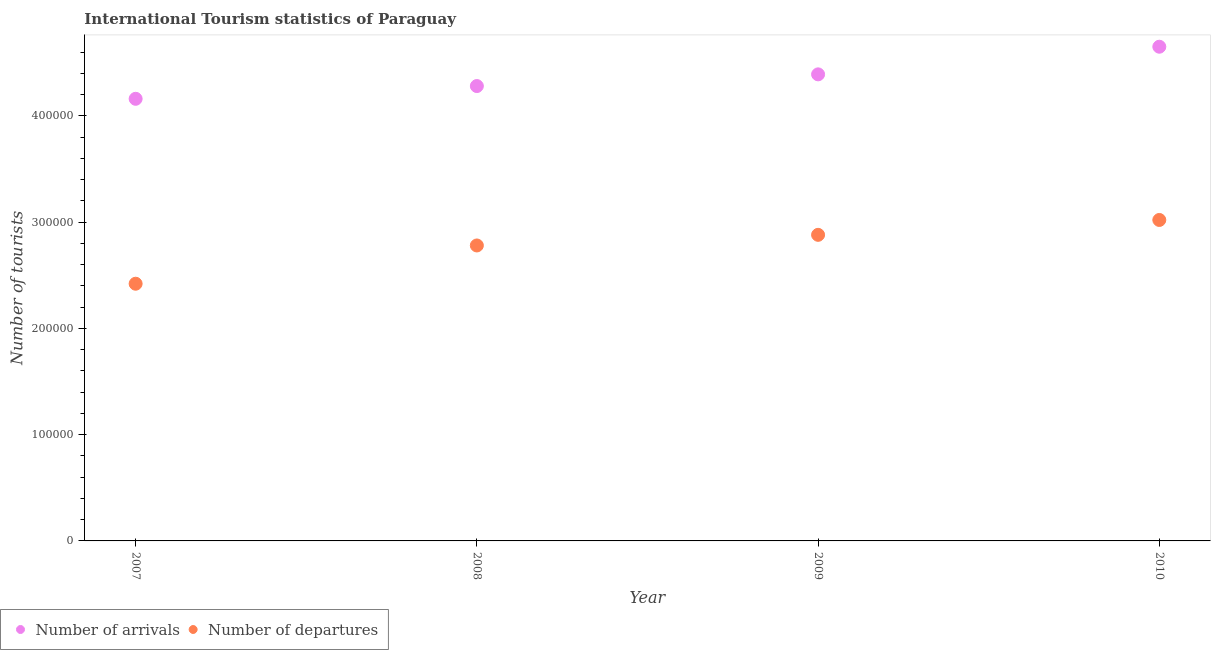Is the number of dotlines equal to the number of legend labels?
Provide a succinct answer. Yes. What is the number of tourist arrivals in 2009?
Provide a succinct answer. 4.39e+05. Across all years, what is the maximum number of tourist departures?
Keep it short and to the point. 3.02e+05. Across all years, what is the minimum number of tourist arrivals?
Keep it short and to the point. 4.16e+05. In which year was the number of tourist departures minimum?
Your answer should be very brief. 2007. What is the total number of tourist arrivals in the graph?
Offer a very short reply. 1.75e+06. What is the difference between the number of tourist departures in 2008 and that in 2009?
Make the answer very short. -10000. What is the difference between the number of tourist arrivals in 2007 and the number of tourist departures in 2009?
Keep it short and to the point. 1.28e+05. What is the average number of tourist arrivals per year?
Give a very brief answer. 4.37e+05. In the year 2009, what is the difference between the number of tourist arrivals and number of tourist departures?
Your answer should be compact. 1.51e+05. What is the ratio of the number of tourist arrivals in 2008 to that in 2009?
Provide a succinct answer. 0.97. What is the difference between the highest and the second highest number of tourist arrivals?
Offer a terse response. 2.60e+04. What is the difference between the highest and the lowest number of tourist arrivals?
Offer a very short reply. 4.90e+04. How many years are there in the graph?
Your answer should be very brief. 4. Does the graph contain any zero values?
Keep it short and to the point. No. Where does the legend appear in the graph?
Provide a short and direct response. Bottom left. How many legend labels are there?
Give a very brief answer. 2. What is the title of the graph?
Provide a short and direct response. International Tourism statistics of Paraguay. What is the label or title of the Y-axis?
Give a very brief answer. Number of tourists. What is the Number of tourists in Number of arrivals in 2007?
Offer a terse response. 4.16e+05. What is the Number of tourists in Number of departures in 2007?
Make the answer very short. 2.42e+05. What is the Number of tourists of Number of arrivals in 2008?
Offer a terse response. 4.28e+05. What is the Number of tourists of Number of departures in 2008?
Keep it short and to the point. 2.78e+05. What is the Number of tourists of Number of arrivals in 2009?
Provide a succinct answer. 4.39e+05. What is the Number of tourists of Number of departures in 2009?
Your answer should be compact. 2.88e+05. What is the Number of tourists in Number of arrivals in 2010?
Keep it short and to the point. 4.65e+05. What is the Number of tourists in Number of departures in 2010?
Provide a short and direct response. 3.02e+05. Across all years, what is the maximum Number of tourists in Number of arrivals?
Keep it short and to the point. 4.65e+05. Across all years, what is the maximum Number of tourists of Number of departures?
Ensure brevity in your answer.  3.02e+05. Across all years, what is the minimum Number of tourists in Number of arrivals?
Your response must be concise. 4.16e+05. Across all years, what is the minimum Number of tourists in Number of departures?
Offer a terse response. 2.42e+05. What is the total Number of tourists in Number of arrivals in the graph?
Your response must be concise. 1.75e+06. What is the total Number of tourists of Number of departures in the graph?
Give a very brief answer. 1.11e+06. What is the difference between the Number of tourists of Number of arrivals in 2007 and that in 2008?
Offer a terse response. -1.20e+04. What is the difference between the Number of tourists of Number of departures in 2007 and that in 2008?
Your answer should be compact. -3.60e+04. What is the difference between the Number of tourists of Number of arrivals in 2007 and that in 2009?
Offer a terse response. -2.30e+04. What is the difference between the Number of tourists of Number of departures in 2007 and that in 2009?
Your answer should be compact. -4.60e+04. What is the difference between the Number of tourists in Number of arrivals in 2007 and that in 2010?
Give a very brief answer. -4.90e+04. What is the difference between the Number of tourists of Number of arrivals in 2008 and that in 2009?
Your response must be concise. -1.10e+04. What is the difference between the Number of tourists of Number of arrivals in 2008 and that in 2010?
Make the answer very short. -3.70e+04. What is the difference between the Number of tourists in Number of departures in 2008 and that in 2010?
Keep it short and to the point. -2.40e+04. What is the difference between the Number of tourists in Number of arrivals in 2009 and that in 2010?
Your answer should be very brief. -2.60e+04. What is the difference between the Number of tourists in Number of departures in 2009 and that in 2010?
Your answer should be compact. -1.40e+04. What is the difference between the Number of tourists of Number of arrivals in 2007 and the Number of tourists of Number of departures in 2008?
Provide a short and direct response. 1.38e+05. What is the difference between the Number of tourists of Number of arrivals in 2007 and the Number of tourists of Number of departures in 2009?
Keep it short and to the point. 1.28e+05. What is the difference between the Number of tourists in Number of arrivals in 2007 and the Number of tourists in Number of departures in 2010?
Keep it short and to the point. 1.14e+05. What is the difference between the Number of tourists in Number of arrivals in 2008 and the Number of tourists in Number of departures in 2009?
Provide a short and direct response. 1.40e+05. What is the difference between the Number of tourists of Number of arrivals in 2008 and the Number of tourists of Number of departures in 2010?
Provide a short and direct response. 1.26e+05. What is the difference between the Number of tourists in Number of arrivals in 2009 and the Number of tourists in Number of departures in 2010?
Offer a terse response. 1.37e+05. What is the average Number of tourists in Number of arrivals per year?
Make the answer very short. 4.37e+05. What is the average Number of tourists in Number of departures per year?
Make the answer very short. 2.78e+05. In the year 2007, what is the difference between the Number of tourists in Number of arrivals and Number of tourists in Number of departures?
Offer a terse response. 1.74e+05. In the year 2008, what is the difference between the Number of tourists in Number of arrivals and Number of tourists in Number of departures?
Offer a very short reply. 1.50e+05. In the year 2009, what is the difference between the Number of tourists in Number of arrivals and Number of tourists in Number of departures?
Give a very brief answer. 1.51e+05. In the year 2010, what is the difference between the Number of tourists of Number of arrivals and Number of tourists of Number of departures?
Offer a very short reply. 1.63e+05. What is the ratio of the Number of tourists in Number of departures in 2007 to that in 2008?
Provide a succinct answer. 0.87. What is the ratio of the Number of tourists in Number of arrivals in 2007 to that in 2009?
Your answer should be compact. 0.95. What is the ratio of the Number of tourists in Number of departures in 2007 to that in 2009?
Offer a very short reply. 0.84. What is the ratio of the Number of tourists in Number of arrivals in 2007 to that in 2010?
Offer a very short reply. 0.89. What is the ratio of the Number of tourists in Number of departures in 2007 to that in 2010?
Your response must be concise. 0.8. What is the ratio of the Number of tourists of Number of arrivals in 2008 to that in 2009?
Provide a short and direct response. 0.97. What is the ratio of the Number of tourists in Number of departures in 2008 to that in 2009?
Keep it short and to the point. 0.97. What is the ratio of the Number of tourists in Number of arrivals in 2008 to that in 2010?
Make the answer very short. 0.92. What is the ratio of the Number of tourists of Number of departures in 2008 to that in 2010?
Your answer should be very brief. 0.92. What is the ratio of the Number of tourists of Number of arrivals in 2009 to that in 2010?
Make the answer very short. 0.94. What is the ratio of the Number of tourists of Number of departures in 2009 to that in 2010?
Ensure brevity in your answer.  0.95. What is the difference between the highest and the second highest Number of tourists in Number of arrivals?
Your response must be concise. 2.60e+04. What is the difference between the highest and the second highest Number of tourists in Number of departures?
Offer a very short reply. 1.40e+04. What is the difference between the highest and the lowest Number of tourists in Number of arrivals?
Offer a very short reply. 4.90e+04. 